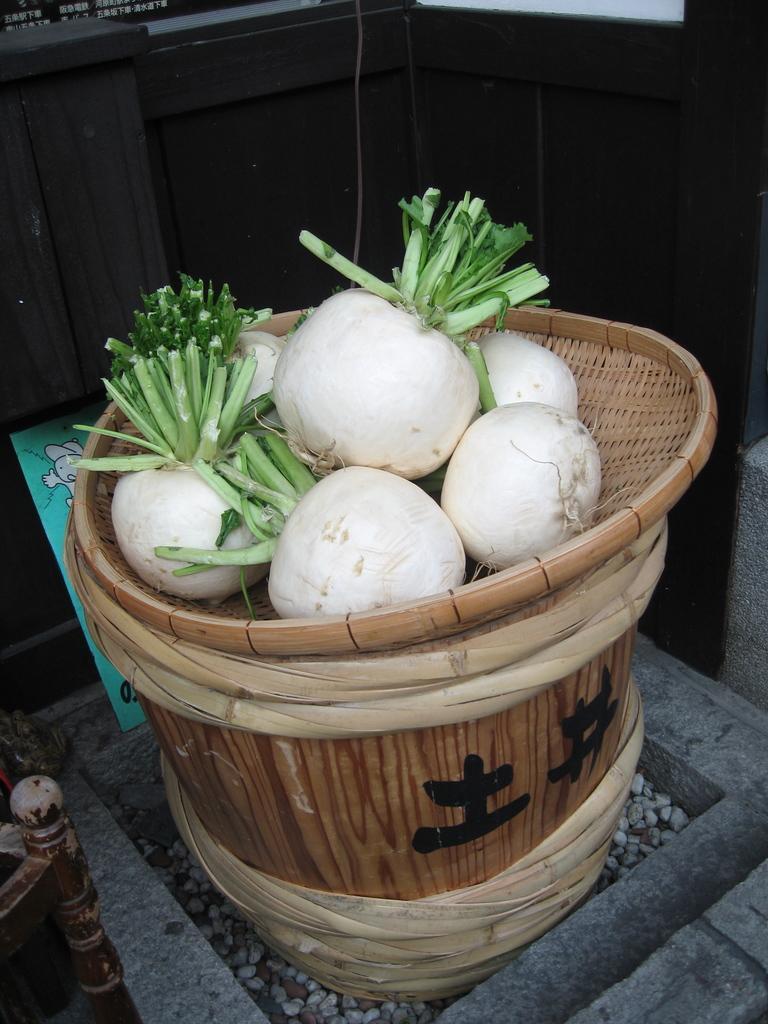How would you summarize this image in a sentence or two? In this image there is a wooden stool, on that there is a wooden bowl, in that bowl there are white onions, in the background there is wooden wall. 